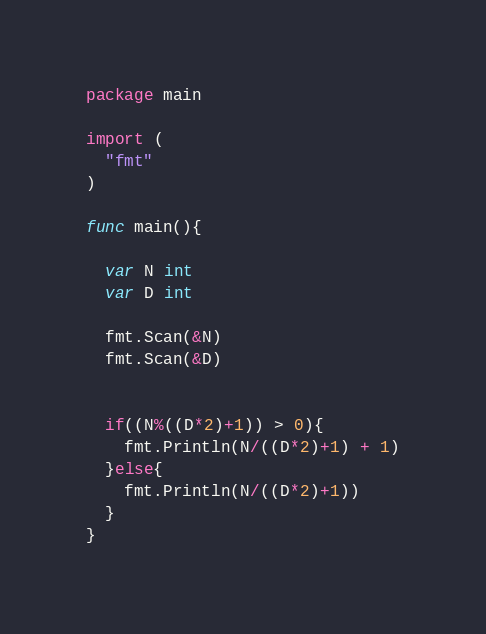Convert code to text. <code><loc_0><loc_0><loc_500><loc_500><_Go_>package main

import (
  "fmt"
)

func main(){
  
  var N int
  var D int
  
  fmt.Scan(&N)
  fmt.Scan(&D)
  
  
  if((N%((D*2)+1)) > 0){
    fmt.Println(N/((D*2)+1) + 1)
  }else{
    fmt.Println(N/((D*2)+1))
  }
}</code> 